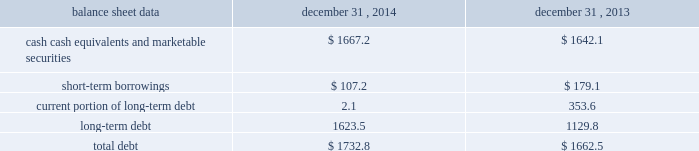Management 2019s discussion and analysis of financial condition and results of operations 2013 ( continued ) ( amounts in millions , except per share amounts ) net cash used in investing activities during 2013 primarily related to payments for capital expenditures and acquisitions .
Capital expenditures of $ 173.0 related primarily to computer hardware and software and leasehold improvements .
We made payments of $ 61.5 related to acquisitions completed during 2013 , net of cash acquired .
Financing activities net cash used in financing activities during 2014 primarily related to the purchase of long-term debt , the repurchase of our common stock and payment of dividends .
During 2014 , we redeemed all $ 350.0 in aggregate principal amount of the 6.25% ( 6.25 % ) notes , repurchased 14.9 shares of our common stock for an aggregate cost of $ 275.1 , including fees , and made dividend payments of $ 159.0 on our common stock .
This was offset by the issuance of $ 500.0 in aggregate principal amount of our 4.20% ( 4.20 % ) notes .
Net cash used in financing activities during 2013 primarily related to the purchase of long-term debt , the repurchase of our common stock and payment of dividends .
We redeemed all $ 600.0 in aggregate principal amount of our 10.00% ( 10.00 % ) notes .
In addition , we repurchased 31.8 shares of our common stock for an aggregate cost of $ 481.8 , including fees , and made dividend payments of $ 126.0 on our common stock .
Foreign exchange rate changes the effect of foreign exchange rate changes on cash and cash equivalents included in the consolidated statements of cash flows resulted in a decrease of $ 101.0 in 2014 .
The decrease was primarily a result of the u.s .
Dollar being stronger than several foreign currencies , including the canadian dollar , brazilian real , australian dollar and the euro as of december 31 , 2014 compared to december 31 , 2013 .
The effect of foreign exchange rate changes on cash and cash equivalents included in the consolidated statements of cash flows resulted in a decrease of $ 94.1 in 2013 .
The decrease was primarily a result of the u.s .
Dollar being stronger than several foreign currencies , including the australian dollar , brazilian real , canadian dollar , japanese yen , and south african rand as of december 31 , 2013 compared to december 31 , 2012. .
Liquidity outlook we expect our cash flow from operations , cash and cash equivalents to be sufficient to meet our anticipated operating requirements at a minimum for the next twelve months .
We also have a committed corporate credit facility as well as uncommitted facilities available to support our operating needs .
We continue to maintain a disciplined approach to managing liquidity , with flexibility over significant uses of cash , including our capital expenditures , cash used for new acquisitions , our common stock repurchase program and our common stock dividends .
From time to time , we evaluate market conditions and financing alternatives for opportunities to raise additional funds or otherwise improve our liquidity profile , enhance our financial flexibility and manage market risk .
Our ability to access the capital markets depends on a number of factors , which include those specific to us , such as our credit rating , and those related to the financial markets , such as the amount or terms of available credit .
There can be no guarantee that we would be able to access new sources of liquidity on commercially reasonable terms , or at all. .
What is the percentage change in the total debt from 2013 to 2014? 
Computations: ((1732.8 - 1662.5) / 1662.5)
Answer: 0.04229. Management 2019s discussion and analysis of financial condition and results of operations 2013 ( continued ) ( amounts in millions , except per share amounts ) net cash used in investing activities during 2013 primarily related to payments for capital expenditures and acquisitions .
Capital expenditures of $ 173.0 related primarily to computer hardware and software and leasehold improvements .
We made payments of $ 61.5 related to acquisitions completed during 2013 , net of cash acquired .
Financing activities net cash used in financing activities during 2014 primarily related to the purchase of long-term debt , the repurchase of our common stock and payment of dividends .
During 2014 , we redeemed all $ 350.0 in aggregate principal amount of the 6.25% ( 6.25 % ) notes , repurchased 14.9 shares of our common stock for an aggregate cost of $ 275.1 , including fees , and made dividend payments of $ 159.0 on our common stock .
This was offset by the issuance of $ 500.0 in aggregate principal amount of our 4.20% ( 4.20 % ) notes .
Net cash used in financing activities during 2013 primarily related to the purchase of long-term debt , the repurchase of our common stock and payment of dividends .
We redeemed all $ 600.0 in aggregate principal amount of our 10.00% ( 10.00 % ) notes .
In addition , we repurchased 31.8 shares of our common stock for an aggregate cost of $ 481.8 , including fees , and made dividend payments of $ 126.0 on our common stock .
Foreign exchange rate changes the effect of foreign exchange rate changes on cash and cash equivalents included in the consolidated statements of cash flows resulted in a decrease of $ 101.0 in 2014 .
The decrease was primarily a result of the u.s .
Dollar being stronger than several foreign currencies , including the canadian dollar , brazilian real , australian dollar and the euro as of december 31 , 2014 compared to december 31 , 2013 .
The effect of foreign exchange rate changes on cash and cash equivalents included in the consolidated statements of cash flows resulted in a decrease of $ 94.1 in 2013 .
The decrease was primarily a result of the u.s .
Dollar being stronger than several foreign currencies , including the australian dollar , brazilian real , canadian dollar , japanese yen , and south african rand as of december 31 , 2013 compared to december 31 , 2012. .
Liquidity outlook we expect our cash flow from operations , cash and cash equivalents to be sufficient to meet our anticipated operating requirements at a minimum for the next twelve months .
We also have a committed corporate credit facility as well as uncommitted facilities available to support our operating needs .
We continue to maintain a disciplined approach to managing liquidity , with flexibility over significant uses of cash , including our capital expenditures , cash used for new acquisitions , our common stock repurchase program and our common stock dividends .
From time to time , we evaluate market conditions and financing alternatives for opportunities to raise additional funds or otherwise improve our liquidity profile , enhance our financial flexibility and manage market risk .
Our ability to access the capital markets depends on a number of factors , which include those specific to us , such as our credit rating , and those related to the financial markets , such as the amount or terms of available credit .
There can be no guarantee that we would be able to access new sources of liquidity on commercially reasonable terms , or at all. .
What is the net change in cash , cash equivalents and marketable securities in 2014? 
Computations: (1667.2 - 1642.1)
Answer: 25.1. 